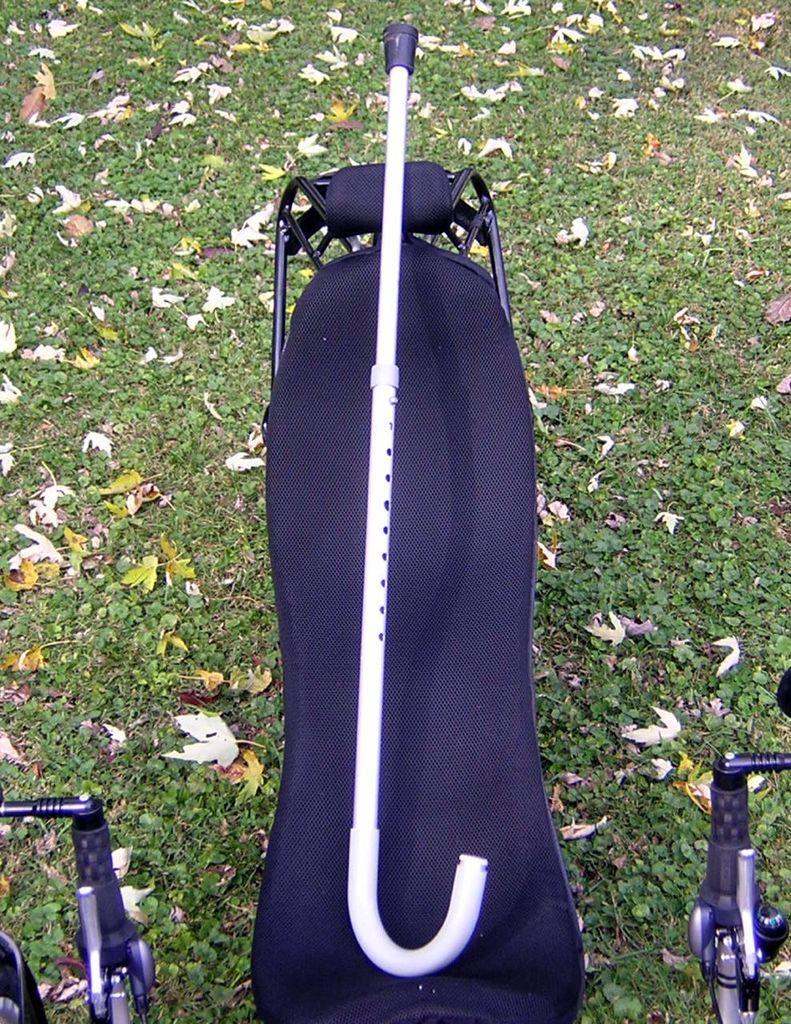Please provide a concise description of this image. In this picture there is a flat bench in the center. On the bench, there is a walking stick. Below it there is grass with dried leaves. 